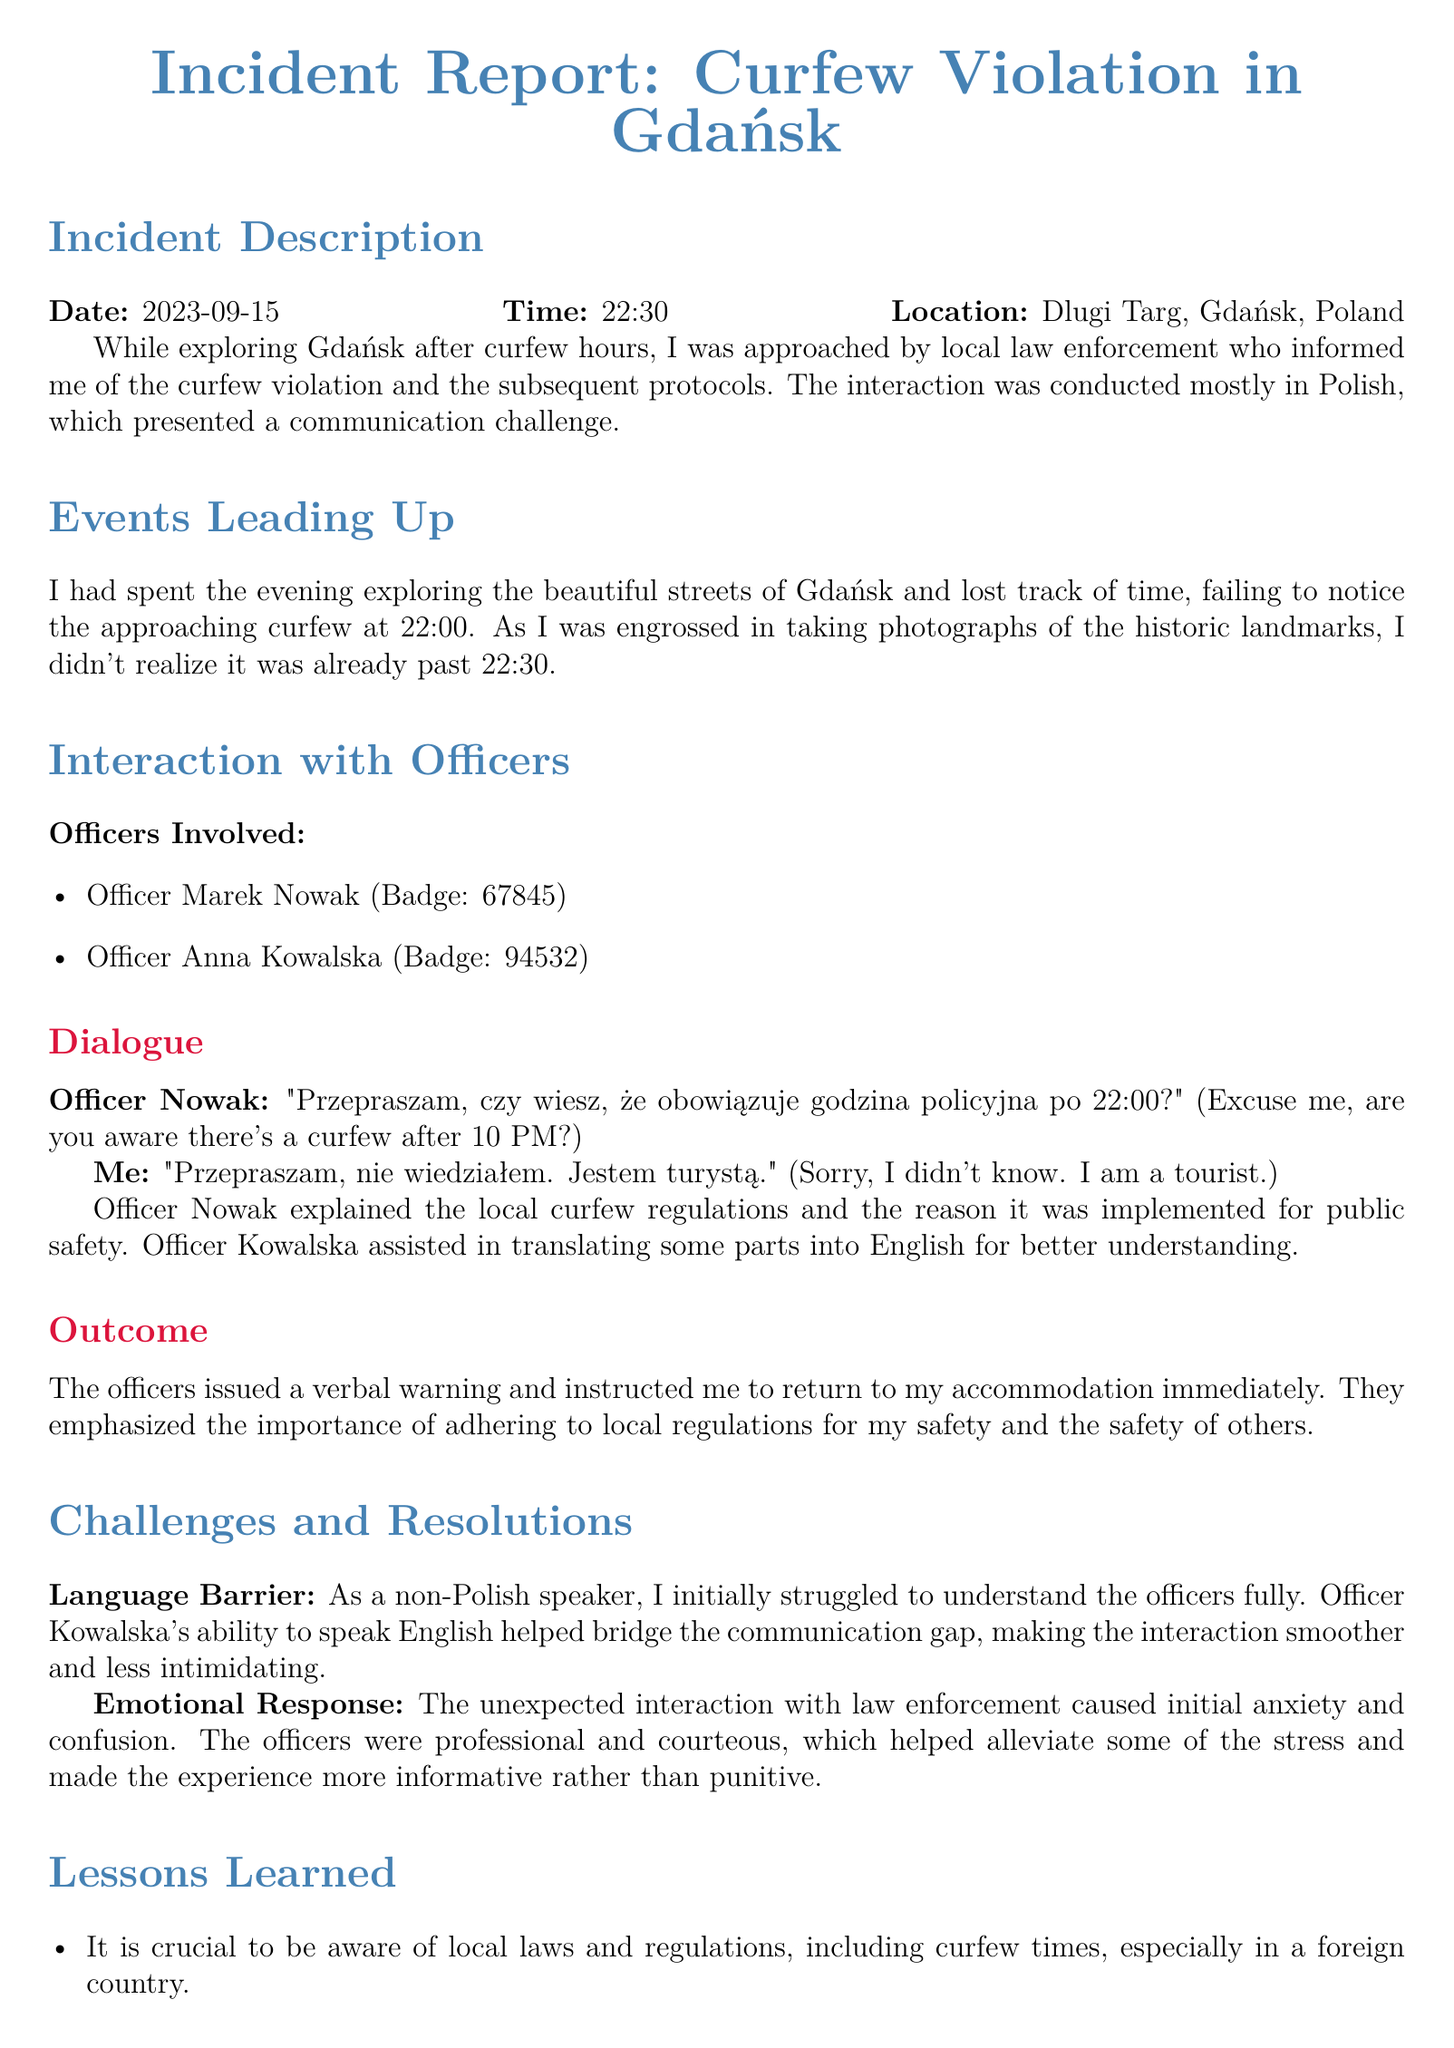What was the date of the incident? The date is specified at the beginning of the incident description section.
Answer: 2023-09-15 What were the names of the officers involved? The names of the officers are listed under the "Officers Involved" section.
Answer: Marek Nowak, Anna Kowalska What time did the curfew start? The curfew time is mentioned when discussing the officers' dialogue about the violation.
Answer: 22:00 What was the location of the incident? The location is provided in the incident description section.
Answer: Dlugi Targ, Gdańsk, Poland What type of warning was issued? The outcome section summarizes the consequence of the interaction.
Answer: Verbal warning What was a key challenge faced during the interaction? The challenges are outlined in a specific section that addresses issues encountered.
Answer: Language Barrier How did the officers assist during the interaction? The document mentions the role of one officer in facilitating communication.
Answer: Translating some parts into English What is one lesson learned from the incident? Lessons learned are listed in their own section, highlighting important takeaways.
Answer: Be aware of local laws and regulations What is a recommendation for future travelers? The document includes specific advice directed at travelers under recommendations.
Answer: Learn basic Polish phrases 